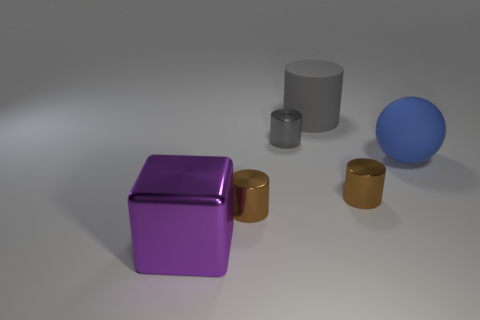The big metal object has what color?
Make the answer very short. Purple. What is the size of the metallic cylinder behind the rubber sphere?
Offer a very short reply. Small. There is a brown shiny object that is right of the big thing that is behind the sphere; what number of large gray rubber cylinders are on the right side of it?
Keep it short and to the point. 0. What is the color of the rubber object that is left of the brown metal object that is right of the rubber cylinder?
Offer a very short reply. Gray. Is there a gray rubber cylinder of the same size as the gray metallic object?
Keep it short and to the point. No. The blue sphere behind the brown shiny thing left of the tiny brown shiny cylinder that is right of the large gray matte cylinder is made of what material?
Your response must be concise. Rubber. How many purple metallic objects are behind the rubber object that is behind the blue rubber object?
Ensure brevity in your answer.  0. Do the rubber thing that is left of the blue rubber object and the purple metal object have the same size?
Offer a very short reply. Yes. What number of tiny brown things have the same shape as the blue object?
Provide a succinct answer. 0. What shape is the big gray matte thing?
Keep it short and to the point. Cylinder. 